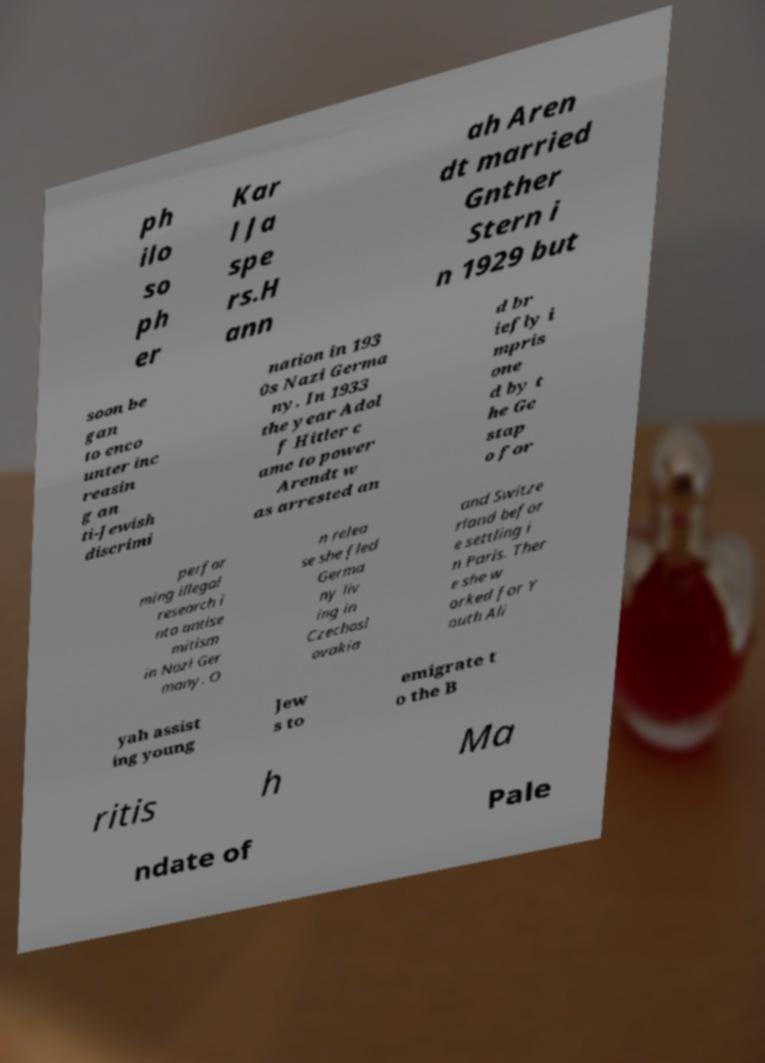There's text embedded in this image that I need extracted. Can you transcribe it verbatim? ph ilo so ph er Kar l Ja spe rs.H ann ah Aren dt married Gnther Stern i n 1929 but soon be gan to enco unter inc reasin g an ti-Jewish discrimi nation in 193 0s Nazi Germa ny. In 1933 the year Adol f Hitler c ame to power Arendt w as arrested an d br iefly i mpris one d by t he Ge stap o for perfor ming illegal research i nto antise mitism in Nazi Ger many. O n relea se she fled Germa ny liv ing in Czechosl ovakia and Switze rland befor e settling i n Paris. Ther e she w orked for Y outh Ali yah assist ing young Jew s to emigrate t o the B ritis h Ma ndate of Pale 